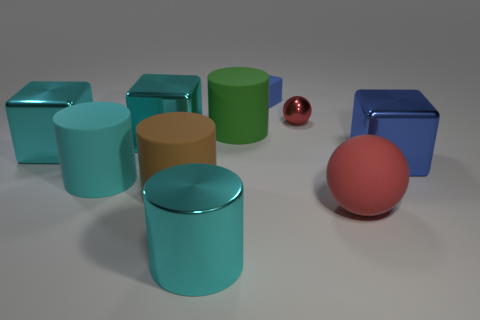What is the relative size of the red sphere compared to the other objects? The red sphere is significantly smaller than the cylinders and the peach-colored sphere, making it the smallest object in the image. 